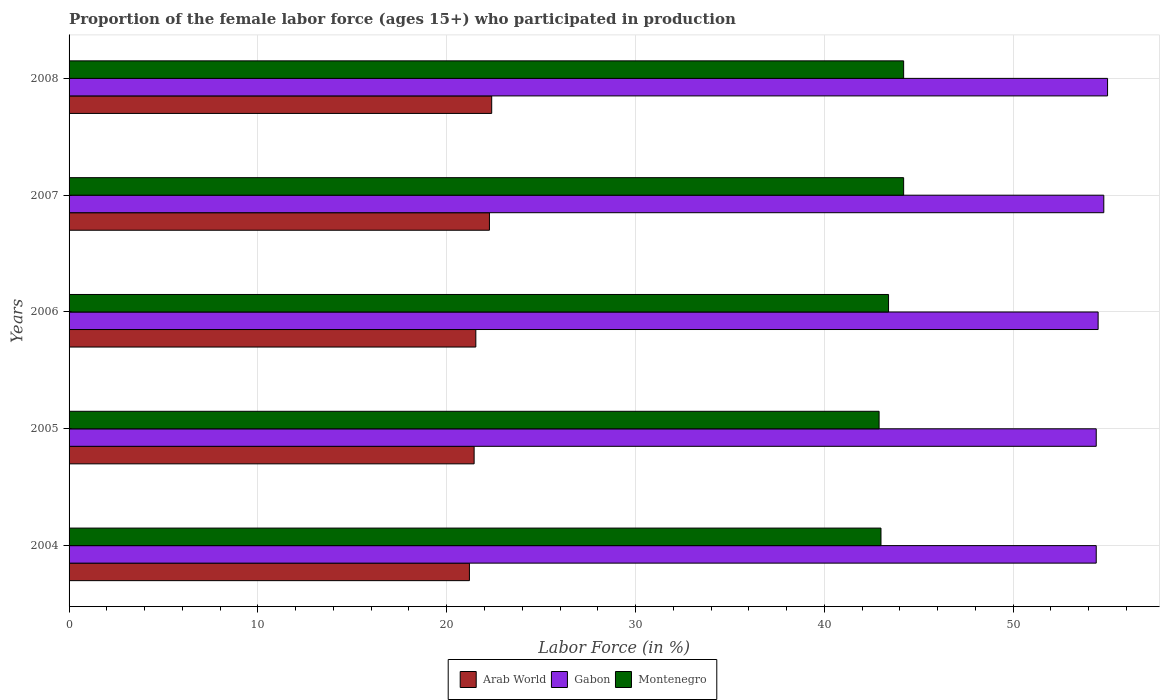How many bars are there on the 4th tick from the top?
Make the answer very short. 3. In how many cases, is the number of bars for a given year not equal to the number of legend labels?
Ensure brevity in your answer.  0. What is the proportion of the female labor force who participated in production in Arab World in 2005?
Ensure brevity in your answer.  21.45. Across all years, what is the maximum proportion of the female labor force who participated in production in Montenegro?
Provide a short and direct response. 44.2. Across all years, what is the minimum proportion of the female labor force who participated in production in Montenegro?
Provide a succinct answer. 42.9. What is the total proportion of the female labor force who participated in production in Arab World in the graph?
Your answer should be very brief. 108.84. What is the difference between the proportion of the female labor force who participated in production in Gabon in 2006 and that in 2008?
Provide a short and direct response. -0.5. What is the difference between the proportion of the female labor force who participated in production in Montenegro in 2006 and the proportion of the female labor force who participated in production in Gabon in 2005?
Provide a short and direct response. -11. What is the average proportion of the female labor force who participated in production in Arab World per year?
Make the answer very short. 21.77. In the year 2004, what is the difference between the proportion of the female labor force who participated in production in Montenegro and proportion of the female labor force who participated in production in Arab World?
Your answer should be compact. 21.8. In how many years, is the proportion of the female labor force who participated in production in Arab World greater than 42 %?
Offer a terse response. 0. What is the ratio of the proportion of the female labor force who participated in production in Gabon in 2007 to that in 2008?
Your response must be concise. 1. Is the proportion of the female labor force who participated in production in Gabon in 2005 less than that in 2006?
Offer a terse response. Yes. What is the difference between the highest and the second highest proportion of the female labor force who participated in production in Arab World?
Provide a succinct answer. 0.12. What is the difference between the highest and the lowest proportion of the female labor force who participated in production in Arab World?
Your response must be concise. 1.18. What does the 2nd bar from the top in 2004 represents?
Give a very brief answer. Gabon. What does the 3rd bar from the bottom in 2007 represents?
Keep it short and to the point. Montenegro. Is it the case that in every year, the sum of the proportion of the female labor force who participated in production in Montenegro and proportion of the female labor force who participated in production in Arab World is greater than the proportion of the female labor force who participated in production in Gabon?
Your response must be concise. Yes. How many bars are there?
Offer a terse response. 15. Are all the bars in the graph horizontal?
Offer a very short reply. Yes. How many years are there in the graph?
Ensure brevity in your answer.  5. Where does the legend appear in the graph?
Your answer should be compact. Bottom center. How are the legend labels stacked?
Provide a succinct answer. Horizontal. What is the title of the graph?
Keep it short and to the point. Proportion of the female labor force (ages 15+) who participated in production. Does "Faeroe Islands" appear as one of the legend labels in the graph?
Make the answer very short. No. What is the Labor Force (in %) of Arab World in 2004?
Keep it short and to the point. 21.2. What is the Labor Force (in %) in Gabon in 2004?
Provide a short and direct response. 54.4. What is the Labor Force (in %) of Arab World in 2005?
Offer a terse response. 21.45. What is the Labor Force (in %) in Gabon in 2005?
Give a very brief answer. 54.4. What is the Labor Force (in %) in Montenegro in 2005?
Keep it short and to the point. 42.9. What is the Labor Force (in %) of Arab World in 2006?
Offer a terse response. 21.54. What is the Labor Force (in %) in Gabon in 2006?
Offer a very short reply. 54.5. What is the Labor Force (in %) in Montenegro in 2006?
Keep it short and to the point. 43.4. What is the Labor Force (in %) of Arab World in 2007?
Your answer should be very brief. 22.26. What is the Labor Force (in %) in Gabon in 2007?
Your response must be concise. 54.8. What is the Labor Force (in %) in Montenegro in 2007?
Make the answer very short. 44.2. What is the Labor Force (in %) in Arab World in 2008?
Offer a terse response. 22.38. What is the Labor Force (in %) of Montenegro in 2008?
Keep it short and to the point. 44.2. Across all years, what is the maximum Labor Force (in %) in Arab World?
Keep it short and to the point. 22.38. Across all years, what is the maximum Labor Force (in %) of Montenegro?
Make the answer very short. 44.2. Across all years, what is the minimum Labor Force (in %) of Arab World?
Ensure brevity in your answer.  21.2. Across all years, what is the minimum Labor Force (in %) of Gabon?
Your answer should be compact. 54.4. Across all years, what is the minimum Labor Force (in %) of Montenegro?
Offer a terse response. 42.9. What is the total Labor Force (in %) in Arab World in the graph?
Keep it short and to the point. 108.84. What is the total Labor Force (in %) in Gabon in the graph?
Your answer should be compact. 273.1. What is the total Labor Force (in %) in Montenegro in the graph?
Your answer should be compact. 217.7. What is the difference between the Labor Force (in %) in Arab World in 2004 and that in 2005?
Give a very brief answer. -0.25. What is the difference between the Labor Force (in %) of Arab World in 2004 and that in 2006?
Give a very brief answer. -0.34. What is the difference between the Labor Force (in %) of Gabon in 2004 and that in 2006?
Provide a succinct answer. -0.1. What is the difference between the Labor Force (in %) of Arab World in 2004 and that in 2007?
Provide a short and direct response. -1.06. What is the difference between the Labor Force (in %) of Arab World in 2004 and that in 2008?
Offer a terse response. -1.18. What is the difference between the Labor Force (in %) in Gabon in 2004 and that in 2008?
Offer a very short reply. -0.6. What is the difference between the Labor Force (in %) of Arab World in 2005 and that in 2006?
Provide a short and direct response. -0.09. What is the difference between the Labor Force (in %) of Arab World in 2005 and that in 2007?
Provide a short and direct response. -0.81. What is the difference between the Labor Force (in %) in Montenegro in 2005 and that in 2007?
Make the answer very short. -1.3. What is the difference between the Labor Force (in %) in Arab World in 2005 and that in 2008?
Give a very brief answer. -0.93. What is the difference between the Labor Force (in %) in Montenegro in 2005 and that in 2008?
Your answer should be very brief. -1.3. What is the difference between the Labor Force (in %) in Arab World in 2006 and that in 2007?
Give a very brief answer. -0.72. What is the difference between the Labor Force (in %) in Gabon in 2006 and that in 2007?
Offer a very short reply. -0.3. What is the difference between the Labor Force (in %) of Arab World in 2006 and that in 2008?
Ensure brevity in your answer.  -0.84. What is the difference between the Labor Force (in %) in Gabon in 2006 and that in 2008?
Your answer should be very brief. -0.5. What is the difference between the Labor Force (in %) of Arab World in 2007 and that in 2008?
Offer a terse response. -0.12. What is the difference between the Labor Force (in %) of Montenegro in 2007 and that in 2008?
Provide a short and direct response. 0. What is the difference between the Labor Force (in %) of Arab World in 2004 and the Labor Force (in %) of Gabon in 2005?
Your answer should be very brief. -33.2. What is the difference between the Labor Force (in %) of Arab World in 2004 and the Labor Force (in %) of Montenegro in 2005?
Make the answer very short. -21.7. What is the difference between the Labor Force (in %) of Arab World in 2004 and the Labor Force (in %) of Gabon in 2006?
Your answer should be compact. -33.3. What is the difference between the Labor Force (in %) in Arab World in 2004 and the Labor Force (in %) in Montenegro in 2006?
Keep it short and to the point. -22.2. What is the difference between the Labor Force (in %) in Gabon in 2004 and the Labor Force (in %) in Montenegro in 2006?
Make the answer very short. 11. What is the difference between the Labor Force (in %) in Arab World in 2004 and the Labor Force (in %) in Gabon in 2007?
Provide a succinct answer. -33.6. What is the difference between the Labor Force (in %) in Arab World in 2004 and the Labor Force (in %) in Montenegro in 2007?
Give a very brief answer. -23. What is the difference between the Labor Force (in %) of Gabon in 2004 and the Labor Force (in %) of Montenegro in 2007?
Your answer should be very brief. 10.2. What is the difference between the Labor Force (in %) of Arab World in 2004 and the Labor Force (in %) of Gabon in 2008?
Ensure brevity in your answer.  -33.8. What is the difference between the Labor Force (in %) of Arab World in 2004 and the Labor Force (in %) of Montenegro in 2008?
Offer a terse response. -23. What is the difference between the Labor Force (in %) of Gabon in 2004 and the Labor Force (in %) of Montenegro in 2008?
Make the answer very short. 10.2. What is the difference between the Labor Force (in %) of Arab World in 2005 and the Labor Force (in %) of Gabon in 2006?
Offer a very short reply. -33.05. What is the difference between the Labor Force (in %) of Arab World in 2005 and the Labor Force (in %) of Montenegro in 2006?
Your answer should be very brief. -21.95. What is the difference between the Labor Force (in %) of Arab World in 2005 and the Labor Force (in %) of Gabon in 2007?
Give a very brief answer. -33.35. What is the difference between the Labor Force (in %) of Arab World in 2005 and the Labor Force (in %) of Montenegro in 2007?
Your answer should be very brief. -22.75. What is the difference between the Labor Force (in %) of Gabon in 2005 and the Labor Force (in %) of Montenegro in 2007?
Your response must be concise. 10.2. What is the difference between the Labor Force (in %) of Arab World in 2005 and the Labor Force (in %) of Gabon in 2008?
Provide a short and direct response. -33.55. What is the difference between the Labor Force (in %) of Arab World in 2005 and the Labor Force (in %) of Montenegro in 2008?
Offer a very short reply. -22.75. What is the difference between the Labor Force (in %) of Arab World in 2006 and the Labor Force (in %) of Gabon in 2007?
Give a very brief answer. -33.26. What is the difference between the Labor Force (in %) of Arab World in 2006 and the Labor Force (in %) of Montenegro in 2007?
Your answer should be compact. -22.66. What is the difference between the Labor Force (in %) of Arab World in 2006 and the Labor Force (in %) of Gabon in 2008?
Offer a very short reply. -33.46. What is the difference between the Labor Force (in %) in Arab World in 2006 and the Labor Force (in %) in Montenegro in 2008?
Offer a very short reply. -22.66. What is the difference between the Labor Force (in %) in Arab World in 2007 and the Labor Force (in %) in Gabon in 2008?
Provide a succinct answer. -32.74. What is the difference between the Labor Force (in %) of Arab World in 2007 and the Labor Force (in %) of Montenegro in 2008?
Offer a terse response. -21.94. What is the average Labor Force (in %) in Arab World per year?
Ensure brevity in your answer.  21.77. What is the average Labor Force (in %) in Gabon per year?
Your response must be concise. 54.62. What is the average Labor Force (in %) in Montenegro per year?
Give a very brief answer. 43.54. In the year 2004, what is the difference between the Labor Force (in %) in Arab World and Labor Force (in %) in Gabon?
Provide a succinct answer. -33.2. In the year 2004, what is the difference between the Labor Force (in %) in Arab World and Labor Force (in %) in Montenegro?
Offer a terse response. -21.8. In the year 2004, what is the difference between the Labor Force (in %) in Gabon and Labor Force (in %) in Montenegro?
Offer a terse response. 11.4. In the year 2005, what is the difference between the Labor Force (in %) of Arab World and Labor Force (in %) of Gabon?
Your response must be concise. -32.95. In the year 2005, what is the difference between the Labor Force (in %) in Arab World and Labor Force (in %) in Montenegro?
Keep it short and to the point. -21.45. In the year 2005, what is the difference between the Labor Force (in %) of Gabon and Labor Force (in %) of Montenegro?
Keep it short and to the point. 11.5. In the year 2006, what is the difference between the Labor Force (in %) in Arab World and Labor Force (in %) in Gabon?
Make the answer very short. -32.96. In the year 2006, what is the difference between the Labor Force (in %) of Arab World and Labor Force (in %) of Montenegro?
Your answer should be compact. -21.86. In the year 2007, what is the difference between the Labor Force (in %) in Arab World and Labor Force (in %) in Gabon?
Provide a short and direct response. -32.54. In the year 2007, what is the difference between the Labor Force (in %) in Arab World and Labor Force (in %) in Montenegro?
Give a very brief answer. -21.94. In the year 2008, what is the difference between the Labor Force (in %) of Arab World and Labor Force (in %) of Gabon?
Provide a short and direct response. -32.62. In the year 2008, what is the difference between the Labor Force (in %) in Arab World and Labor Force (in %) in Montenegro?
Your answer should be compact. -21.82. What is the ratio of the Labor Force (in %) in Arab World in 2004 to that in 2005?
Your answer should be compact. 0.99. What is the ratio of the Labor Force (in %) in Gabon in 2004 to that in 2005?
Offer a terse response. 1. What is the ratio of the Labor Force (in %) of Montenegro in 2004 to that in 2005?
Offer a terse response. 1. What is the ratio of the Labor Force (in %) of Arab World in 2004 to that in 2006?
Provide a short and direct response. 0.98. What is the ratio of the Labor Force (in %) in Arab World in 2004 to that in 2007?
Your response must be concise. 0.95. What is the ratio of the Labor Force (in %) of Montenegro in 2004 to that in 2007?
Your answer should be very brief. 0.97. What is the ratio of the Labor Force (in %) in Arab World in 2004 to that in 2008?
Your response must be concise. 0.95. What is the ratio of the Labor Force (in %) of Gabon in 2004 to that in 2008?
Provide a succinct answer. 0.99. What is the ratio of the Labor Force (in %) in Montenegro in 2004 to that in 2008?
Provide a short and direct response. 0.97. What is the ratio of the Labor Force (in %) in Arab World in 2005 to that in 2006?
Your response must be concise. 1. What is the ratio of the Labor Force (in %) in Arab World in 2005 to that in 2007?
Give a very brief answer. 0.96. What is the ratio of the Labor Force (in %) in Gabon in 2005 to that in 2007?
Keep it short and to the point. 0.99. What is the ratio of the Labor Force (in %) in Montenegro in 2005 to that in 2007?
Make the answer very short. 0.97. What is the ratio of the Labor Force (in %) of Arab World in 2005 to that in 2008?
Make the answer very short. 0.96. What is the ratio of the Labor Force (in %) of Montenegro in 2005 to that in 2008?
Make the answer very short. 0.97. What is the ratio of the Labor Force (in %) in Arab World in 2006 to that in 2007?
Provide a short and direct response. 0.97. What is the ratio of the Labor Force (in %) of Montenegro in 2006 to that in 2007?
Make the answer very short. 0.98. What is the ratio of the Labor Force (in %) of Arab World in 2006 to that in 2008?
Ensure brevity in your answer.  0.96. What is the ratio of the Labor Force (in %) in Gabon in 2006 to that in 2008?
Make the answer very short. 0.99. What is the ratio of the Labor Force (in %) of Montenegro in 2006 to that in 2008?
Keep it short and to the point. 0.98. What is the ratio of the Labor Force (in %) of Arab World in 2007 to that in 2008?
Offer a terse response. 0.99. What is the ratio of the Labor Force (in %) in Gabon in 2007 to that in 2008?
Offer a very short reply. 1. What is the difference between the highest and the second highest Labor Force (in %) in Arab World?
Provide a short and direct response. 0.12. What is the difference between the highest and the second highest Labor Force (in %) of Gabon?
Provide a short and direct response. 0.2. What is the difference between the highest and the lowest Labor Force (in %) of Arab World?
Provide a succinct answer. 1.18. What is the difference between the highest and the lowest Labor Force (in %) of Montenegro?
Keep it short and to the point. 1.3. 